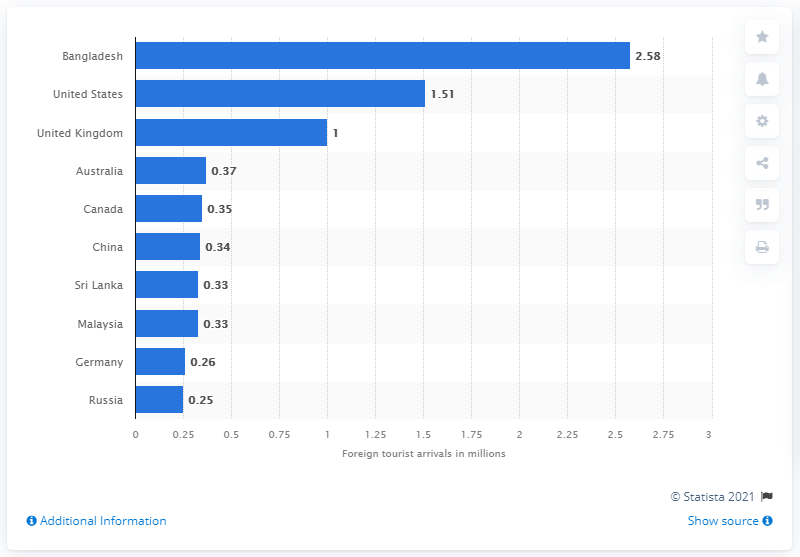List a handful of essential elements in this visual. In 2019, the largest number of foreign tourists arrived in India from Bangladesh. In 2019, the United Kingdom had the highest number of tourists visiting India. In 2019, the number of tourists who traveled to India from Bangladesh was 2.58 million. 